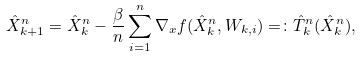Convert formula to latex. <formula><loc_0><loc_0><loc_500><loc_500>\hat { X } _ { k + 1 } ^ { n } = \hat { X } _ { k } ^ { n } - \frac { \beta } { n } \sum _ { i = 1 } ^ { n } \nabla _ { x } f ( \hat { X } _ { k } ^ { n } , W _ { k , i } ) = \colon \hat { T } ^ { n } _ { k } ( \hat { X } _ { k } ^ { n } ) ,</formula> 